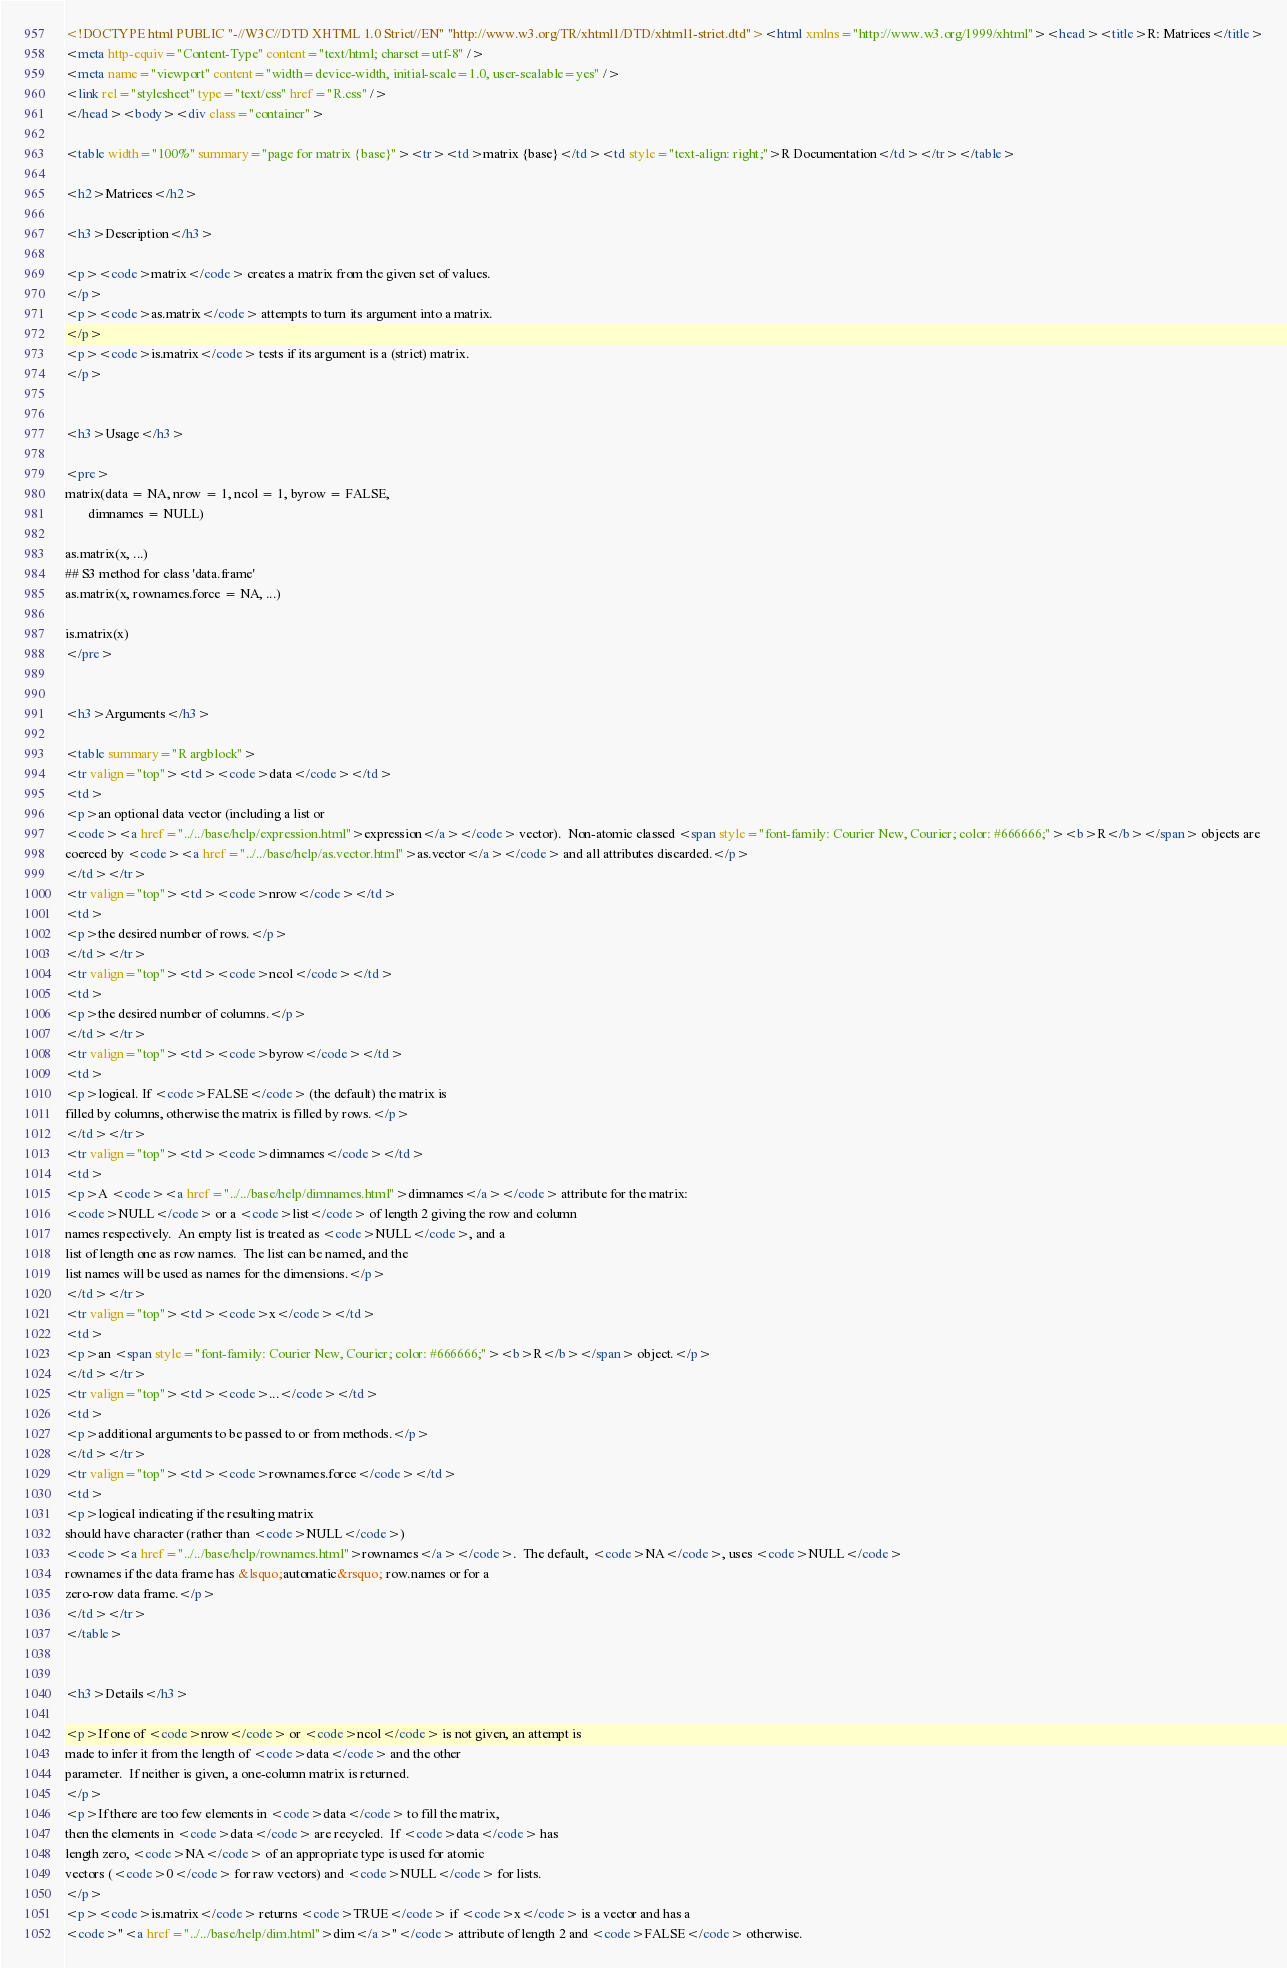Convert code to text. <code><loc_0><loc_0><loc_500><loc_500><_HTML_><!DOCTYPE html PUBLIC "-//W3C//DTD XHTML 1.0 Strict//EN" "http://www.w3.org/TR/xhtml1/DTD/xhtml1-strict.dtd"><html xmlns="http://www.w3.org/1999/xhtml"><head><title>R: Matrices</title>
<meta http-equiv="Content-Type" content="text/html; charset=utf-8" />
<meta name="viewport" content="width=device-width, initial-scale=1.0, user-scalable=yes" />
<link rel="stylesheet" type="text/css" href="R.css" />
</head><body><div class="container">

<table width="100%" summary="page for matrix {base}"><tr><td>matrix {base}</td><td style="text-align: right;">R Documentation</td></tr></table>

<h2>Matrices</h2>

<h3>Description</h3>

<p><code>matrix</code> creates a matrix from the given set of values.
</p>
<p><code>as.matrix</code> attempts to turn its argument into a matrix.
</p>
<p><code>is.matrix</code> tests if its argument is a (strict) matrix.
</p>


<h3>Usage</h3>

<pre>
matrix(data = NA, nrow = 1, ncol = 1, byrow = FALSE,
       dimnames = NULL)

as.matrix(x, ...)
## S3 method for class 'data.frame'
as.matrix(x, rownames.force = NA, ...)

is.matrix(x)
</pre>


<h3>Arguments</h3>

<table summary="R argblock">
<tr valign="top"><td><code>data</code></td>
<td>
<p>an optional data vector (including a list or
<code><a href="../../base/help/expression.html">expression</a></code> vector).  Non-atomic classed <span style="font-family: Courier New, Courier; color: #666666;"><b>R</b></span> objects are
coerced by <code><a href="../../base/help/as.vector.html">as.vector</a></code> and all attributes discarded.</p>
</td></tr>
<tr valign="top"><td><code>nrow</code></td>
<td>
<p>the desired number of rows.</p>
</td></tr>
<tr valign="top"><td><code>ncol</code></td>
<td>
<p>the desired number of columns.</p>
</td></tr>
<tr valign="top"><td><code>byrow</code></td>
<td>
<p>logical. If <code>FALSE</code> (the default) the matrix is
filled by columns, otherwise the matrix is filled by rows.</p>
</td></tr>
<tr valign="top"><td><code>dimnames</code></td>
<td>
<p>A <code><a href="../../base/help/dimnames.html">dimnames</a></code> attribute for the matrix:
<code>NULL</code> or a <code>list</code> of length 2 giving the row and column
names respectively.  An empty list is treated as <code>NULL</code>, and a
list of length one as row names.  The list can be named, and the
list names will be used as names for the dimensions.</p>
</td></tr>
<tr valign="top"><td><code>x</code></td>
<td>
<p>an <span style="font-family: Courier New, Courier; color: #666666;"><b>R</b></span> object.</p>
</td></tr>
<tr valign="top"><td><code>...</code></td>
<td>
<p>additional arguments to be passed to or from methods.</p>
</td></tr>
<tr valign="top"><td><code>rownames.force</code></td>
<td>
<p>logical indicating if the resulting matrix
should have character (rather than <code>NULL</code>)
<code><a href="../../base/help/rownames.html">rownames</a></code>.  The default, <code>NA</code>, uses <code>NULL</code>
rownames if the data frame has &lsquo;automatic&rsquo; row.names or for a
zero-row data frame.</p>
</td></tr>
</table>


<h3>Details</h3>

<p>If one of <code>nrow</code> or <code>ncol</code> is not given, an attempt is
made to infer it from the length of <code>data</code> and the other
parameter.  If neither is given, a one-column matrix is returned.
</p>
<p>If there are too few elements in <code>data</code> to fill the matrix,
then the elements in <code>data</code> are recycled.  If <code>data</code> has
length zero, <code>NA</code> of an appropriate type is used for atomic
vectors (<code>0</code> for raw vectors) and <code>NULL</code> for lists.
</p>
<p><code>is.matrix</code> returns <code>TRUE</code> if <code>x</code> is a vector and has a
<code>"<a href="../../base/help/dim.html">dim</a>"</code> attribute of length 2 and <code>FALSE</code> otherwise.</code> 